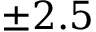<formula> <loc_0><loc_0><loc_500><loc_500>\pm 2 . 5</formula> 